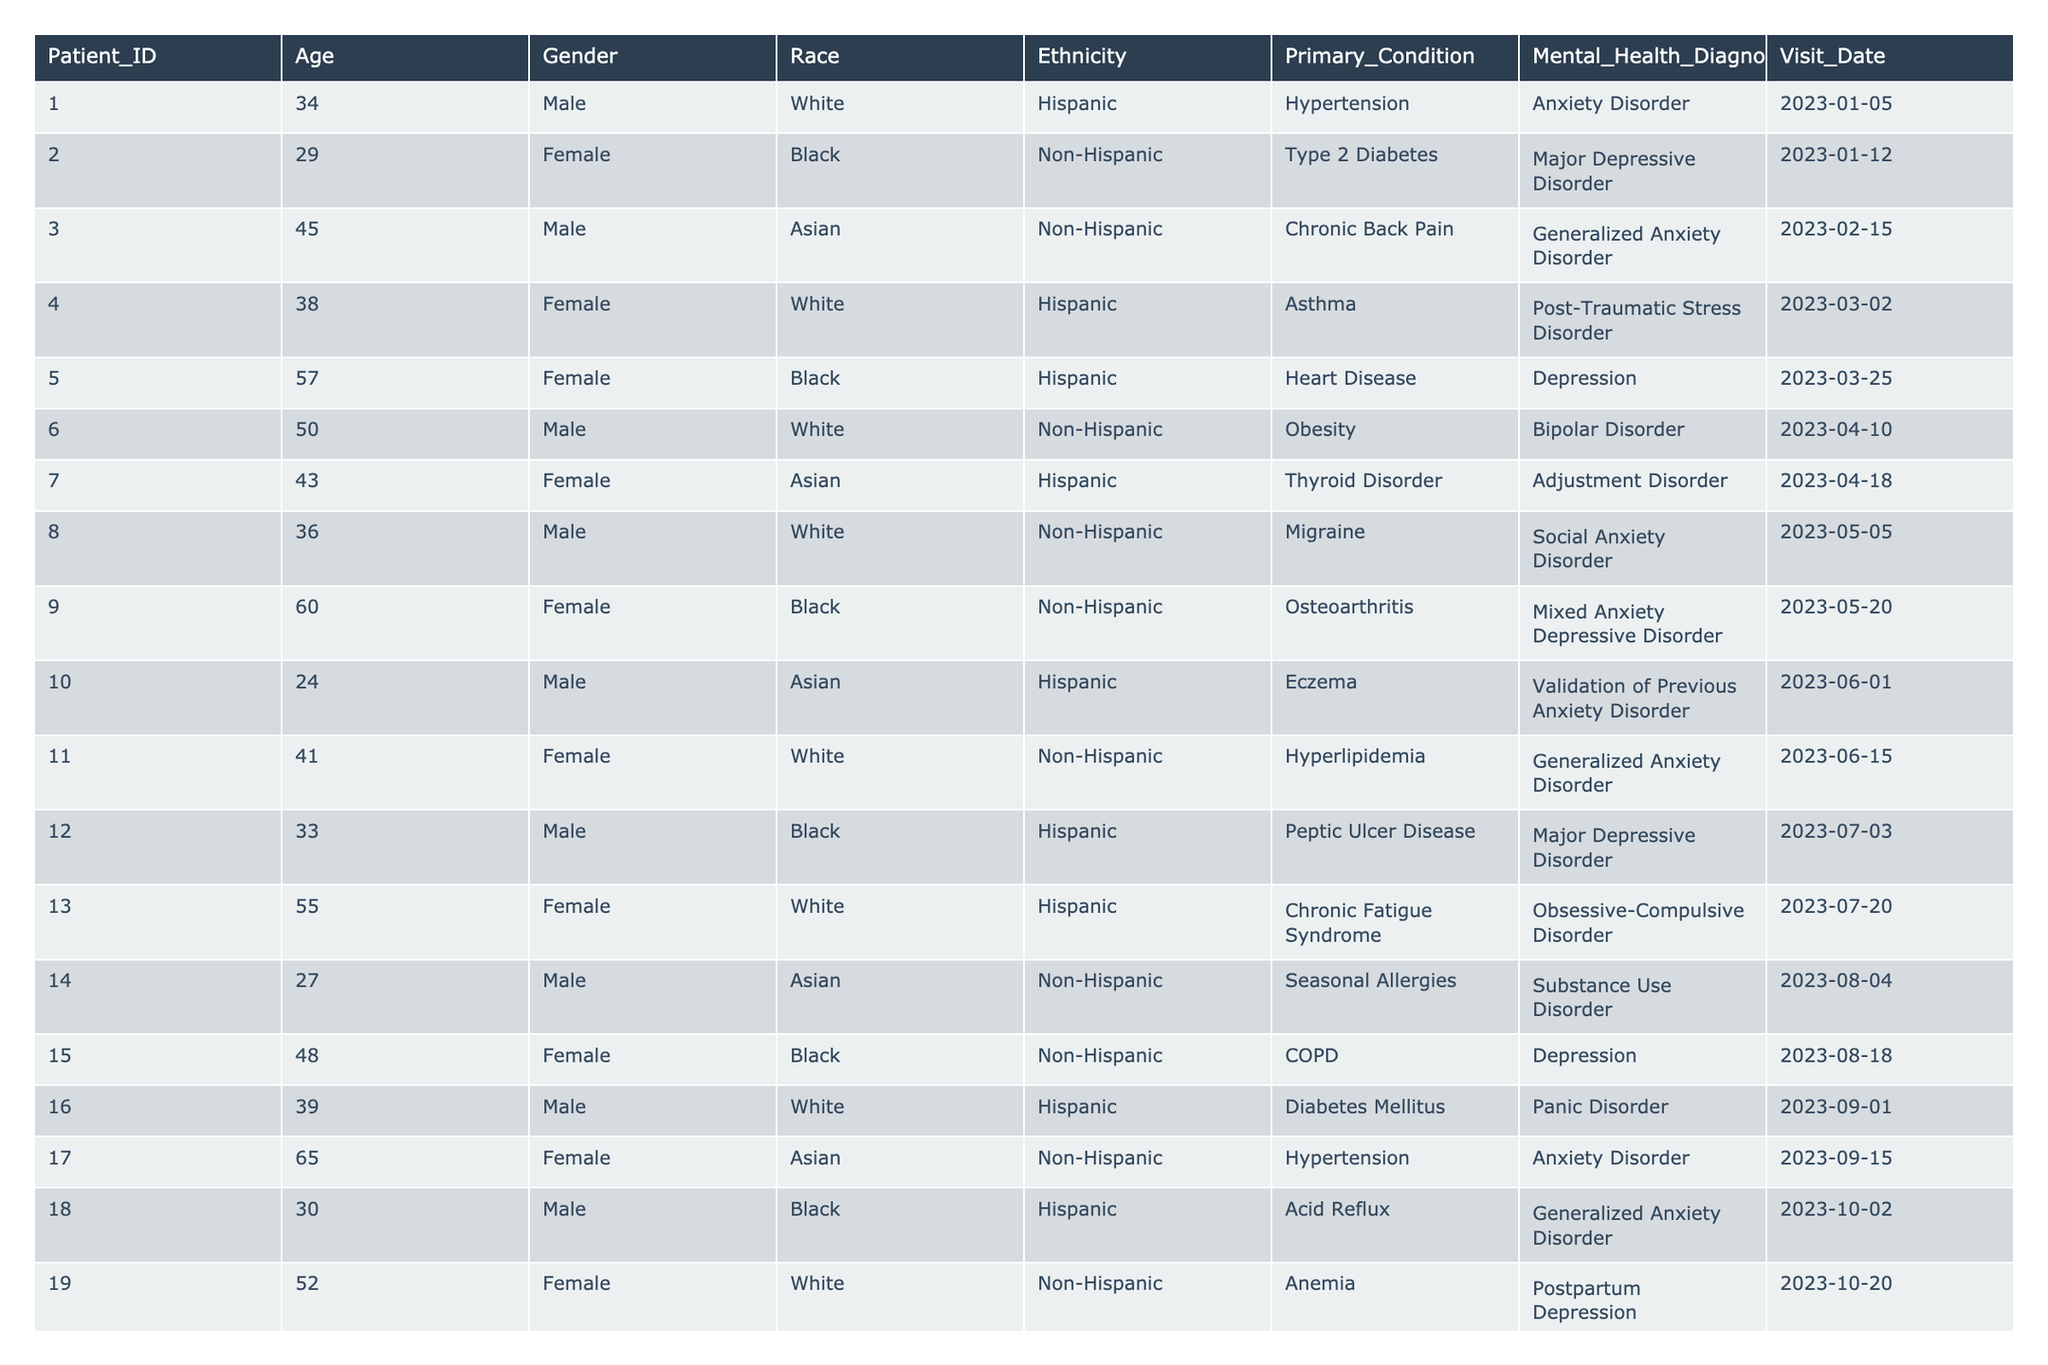What is the most common mental health diagnosis among the patients? To find the most common mental health diagnosis, I will count the occurrences of each diagnosis and identify the one with the highest frequency. The diagnoses are: Anxiety Disorder (4), Major Depressive Disorder (4), Generalized Anxiety Disorder (3), and others with fewer occurrences. Anxiety Disorder and Major Depressive Disorder tie, but Anxiety Disorder appears first in the table as a common diagnosis.
Answer: Anxiety Disorder How many male patients have a mental health diagnosis? I will count the number of patients in the table where the Gender is Male and they have a mental health diagnosis listed. There are 10 Male patients in total, each associated with a diagnosis, so the count is 10.
Answer: 10 Which age group has the highest number of patients with mental health diagnoses? I will group the patients by age intervals (e.g., 20-29, 30-39, etc.) and count how many patients fall into each group with a mental health diagnosis. The age group 30-39 has 6 patients, which is the highest.
Answer: 30-39 Is there a relationship between race and mental health diagnosis? To assess this, I will compare the different races and their associated mental health diagnoses. The table shows varied diagnoses across races; therefore, I observe no single race dominating any specific mental health diagnosis. This means there isn't a clear relationship.
Answer: No How many patients over the age of 50 have a mental health diagnosis of Depression? I will first identify patients aged over 50, then check if any of them have a diagnosis of Depression. Upon examining the data, only one patient, the 57-year-old Female (Patient_ID 005), fits the criteria and has Depression.
Answer: 1 What percentage of the patients have a diagnosis of Anxiety Disorder? I will calculate the number of patients diagnosed with Anxiety Disorder (which is 4) divided by the total number of patients (which is 20) and then multiply by 100 for the percentage. Thus, (4/20) * 100 = 20%.
Answer: 20% Among female patients, which mental health diagnosis appears most frequently? I will filter the table to include only female patients, then count the frequency of each mental health diagnosis among them. After analysis, Depression appears most frequently with 3 occurrences.
Answer: Depression How many different primary conditions are associated with the diagnosis of Bipolar Disorder? I will look for the rows where Bipolar Disorder is present and note the associated Primary Condition. In this case, only one primary condition (Obesity) is associated with Bipolar Disorder in the provided data.
Answer: 1 Are there any patients who have both a mental health diagnosis and a primary condition related to diabetes? I will search through the table for any patient with a diagnosis related to mental health who also has a primary condition categorized under diabetes (i.e., Type 2 Diabetes and Diabetes Mellitus). Both Patient_IDs 002 and 016 fit this criterion.
Answer: Yes Which patient has the latest visit date among those diagnosed with Generalized Anxiety Disorder? I will first identify all patients with a diagnosis of Generalized Anxiety Disorder and then compare their Visit Dates to find the latest one. Patient_ID 011 has the latest visit date of 2023-06-15.
Answer: 011 Does the table show that there are more female patients than male patients with mental health diagnoses? I will count the total female patients (12) and male patients (8) with mental health diagnoses to compare. There are more female patients than male patients.
Answer: Yes 